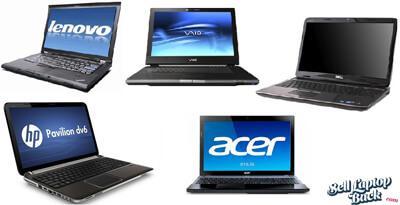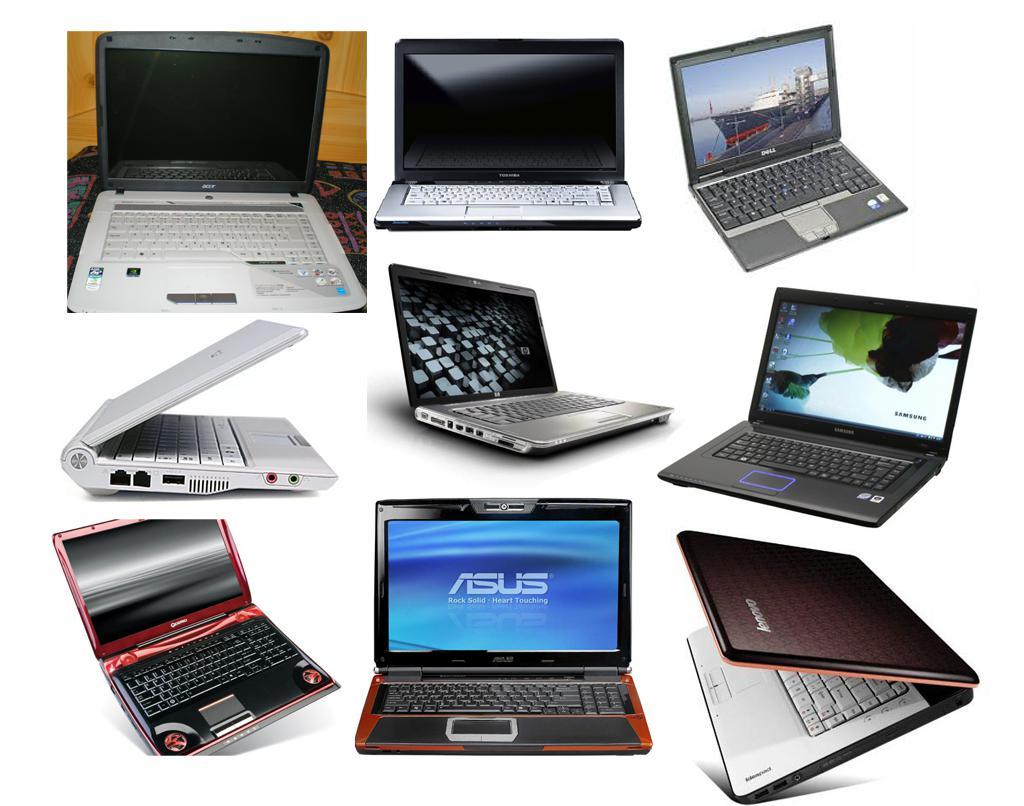The first image is the image on the left, the second image is the image on the right. Assess this claim about the two images: "There is an image of a bird on the screen of one of the computers in the image on the left.". Correct or not? Answer yes or no. No. 